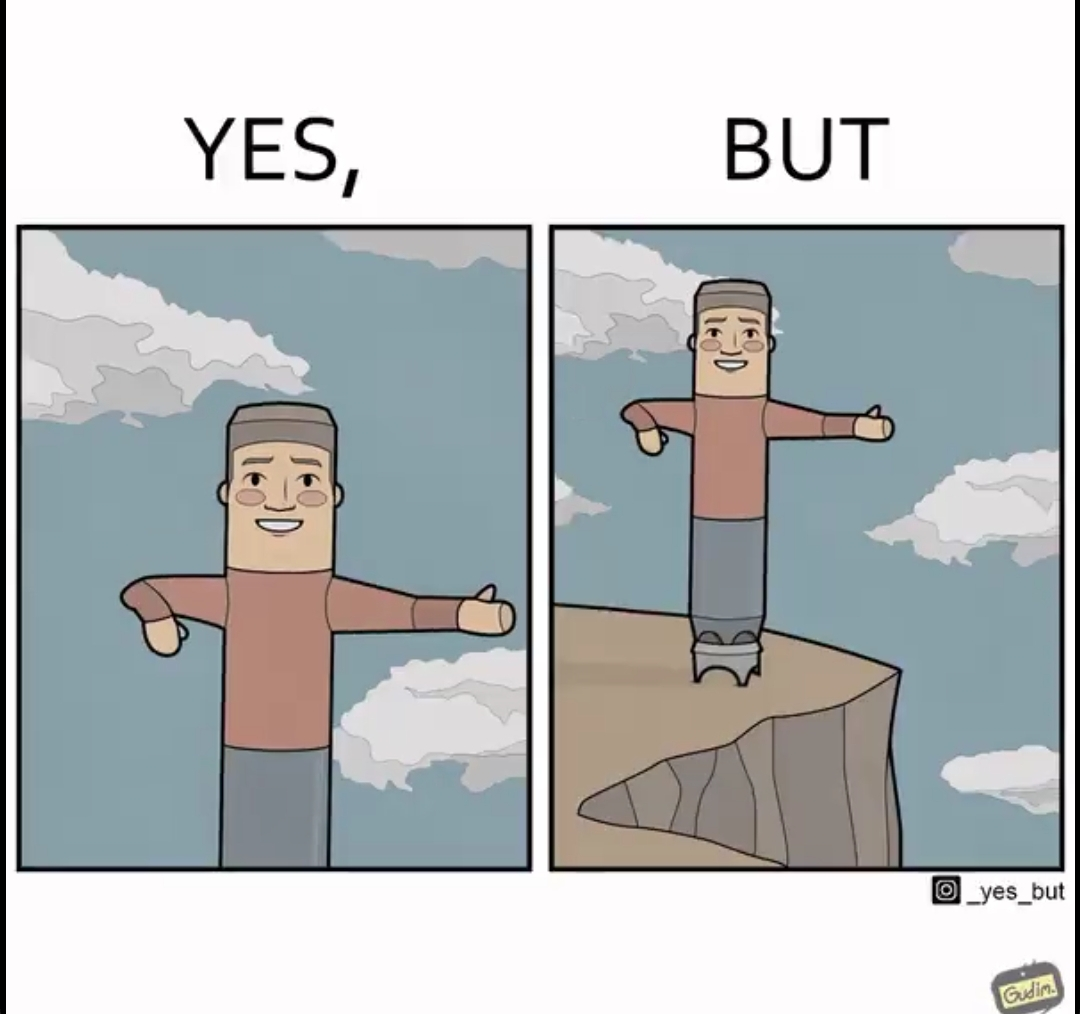Describe the content of this image. The image is ironic, because in the first image a statue is shown with smiling face pointing in some direction but in the second image the same statue is seen as pointing at the wrong path which can cause accidents that too with the smiling face 